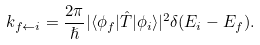Convert formula to latex. <formula><loc_0><loc_0><loc_500><loc_500>k _ { f \leftarrow i } = \frac { 2 \pi } { \hslash } | \langle \phi _ { f } | \hat { T } | \phi _ { i } \rangle | ^ { 2 } \delta ( E _ { i } - E _ { f } ) .</formula> 